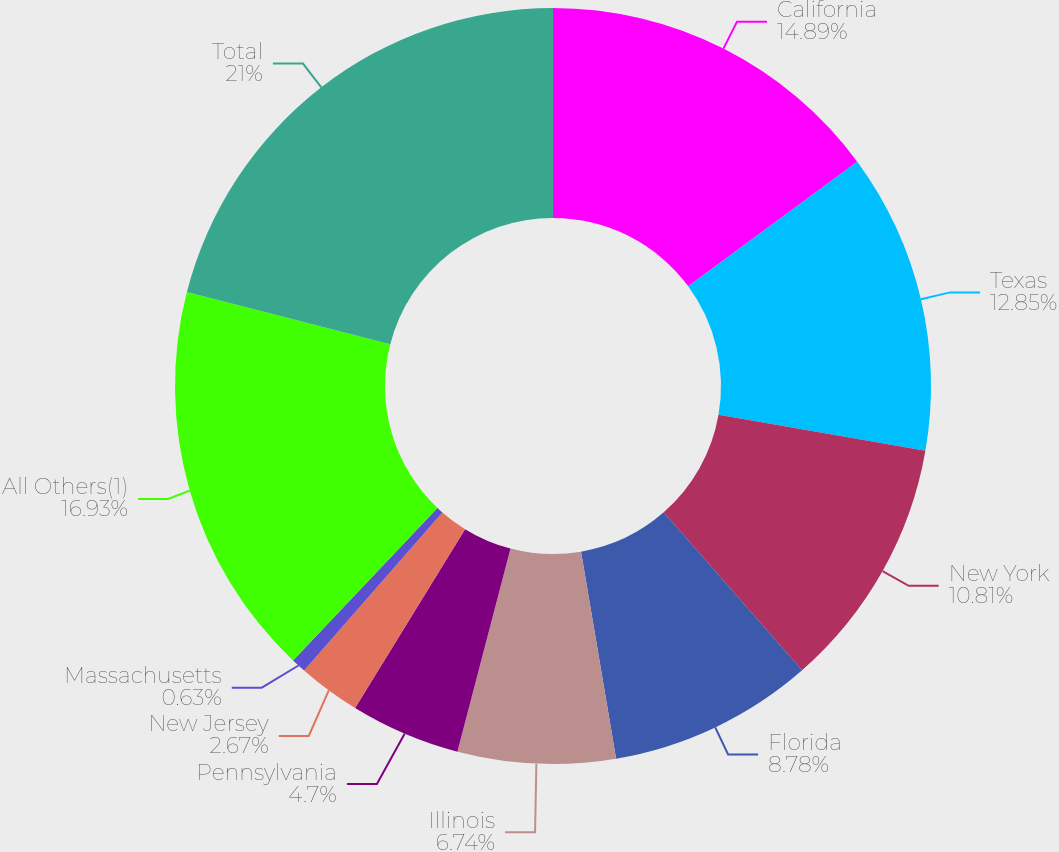Convert chart to OTSL. <chart><loc_0><loc_0><loc_500><loc_500><pie_chart><fcel>California<fcel>Texas<fcel>New York<fcel>Florida<fcel>Illinois<fcel>Pennsylvania<fcel>New Jersey<fcel>Massachusetts<fcel>All Others(1)<fcel>Total<nl><fcel>14.89%<fcel>12.85%<fcel>10.81%<fcel>8.78%<fcel>6.74%<fcel>4.7%<fcel>2.67%<fcel>0.63%<fcel>16.93%<fcel>21.0%<nl></chart> 